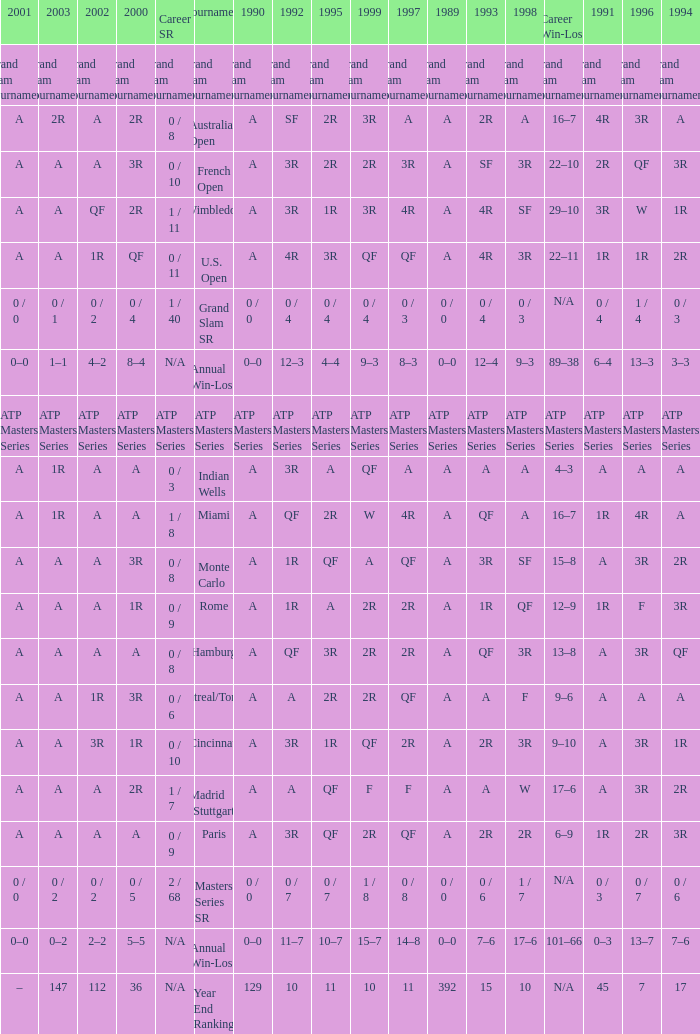Parse the table in full. {'header': ['2001', '2003', '2002', '2000', 'Career SR', 'Tournament', '1990', '1992', '1995', '1999', '1997', '1989', '1993', '1998', 'Career Win-Loss', '1991', '1996', '1994'], 'rows': [['Grand Slam Tournaments', 'Grand Slam Tournaments', 'Grand Slam Tournaments', 'Grand Slam Tournaments', 'Grand Slam Tournaments', 'Grand Slam Tournaments', 'Grand Slam Tournaments', 'Grand Slam Tournaments', 'Grand Slam Tournaments', 'Grand Slam Tournaments', 'Grand Slam Tournaments', 'Grand Slam Tournaments', 'Grand Slam Tournaments', 'Grand Slam Tournaments', 'Grand Slam Tournaments', 'Grand Slam Tournaments', 'Grand Slam Tournaments', 'Grand Slam Tournaments'], ['A', '2R', 'A', '2R', '0 / 8', 'Australian Open', 'A', 'SF', '2R', '3R', 'A', 'A', '2R', 'A', '16–7', '4R', '3R', 'A'], ['A', 'A', 'A', '3R', '0 / 10', 'French Open', 'A', '3R', '2R', '2R', '3R', 'A', 'SF', '3R', '22–10', '2R', 'QF', '3R'], ['A', 'A', 'QF', '2R', '1 / 11', 'Wimbledon', 'A', '3R', '1R', '3R', '4R', 'A', '4R', 'SF', '29–10', '3R', 'W', '1R'], ['A', 'A', '1R', 'QF', '0 / 11', 'U.S. Open', 'A', '4R', '3R', 'QF', 'QF', 'A', '4R', '3R', '22–11', '1R', '1R', '2R'], ['0 / 0', '0 / 1', '0 / 2', '0 / 4', '1 / 40', 'Grand Slam SR', '0 / 0', '0 / 4', '0 / 4', '0 / 4', '0 / 3', '0 / 0', '0 / 4', '0 / 3', 'N/A', '0 / 4', '1 / 4', '0 / 3'], ['0–0', '1–1', '4–2', '8–4', 'N/A', 'Annual Win-Loss', '0–0', '12–3', '4–4', '9–3', '8–3', '0–0', '12–4', '9–3', '89–38', '6–4', '13–3', '3–3'], ['ATP Masters Series', 'ATP Masters Series', 'ATP Masters Series', 'ATP Masters Series', 'ATP Masters Series', 'ATP Masters Series', 'ATP Masters Series', 'ATP Masters Series', 'ATP Masters Series', 'ATP Masters Series', 'ATP Masters Series', 'ATP Masters Series', 'ATP Masters Series', 'ATP Masters Series', 'ATP Masters Series', 'ATP Masters Series', 'ATP Masters Series', 'ATP Masters Series'], ['A', '1R', 'A', 'A', '0 / 3', 'Indian Wells', 'A', '3R', 'A', 'QF', 'A', 'A', 'A', 'A', '4–3', 'A', 'A', 'A'], ['A', '1R', 'A', 'A', '1 / 8', 'Miami', 'A', 'QF', '2R', 'W', '4R', 'A', 'QF', 'A', '16–7', '1R', '4R', 'A'], ['A', 'A', 'A', '3R', '0 / 8', 'Monte Carlo', 'A', '1R', 'QF', 'A', 'QF', 'A', '3R', 'SF', '15–8', 'A', '3R', '2R'], ['A', 'A', 'A', '1R', '0 / 9', 'Rome', 'A', '1R', 'A', '2R', '2R', 'A', '1R', 'QF', '12–9', '1R', 'F', '3R'], ['A', 'A', 'A', 'A', '0 / 8', 'Hamburg', 'A', 'QF', '3R', '2R', '2R', 'A', 'QF', '3R', '13–8', 'A', '3R', 'QF'], ['A', 'A', '1R', '3R', '0 / 6', 'Montreal/Toronto', 'A', 'A', '2R', '2R', 'QF', 'A', 'A', 'F', '9–6', 'A', 'A', 'A'], ['A', 'A', '3R', '1R', '0 / 10', 'Cincinnati', 'A', '3R', '1R', 'QF', '2R', 'A', '2R', '3R', '9–10', 'A', '3R', '1R'], ['A', 'A', 'A', '2R', '1 / 7', 'Madrid (Stuttgart)', 'A', 'A', 'QF', 'F', 'F', 'A', 'A', 'W', '17–6', 'A', '3R', '2R'], ['A', 'A', 'A', 'A', '0 / 9', 'Paris', 'A', '3R', 'QF', '2R', 'QF', 'A', '2R', '2R', '6–9', '1R', '2R', '3R'], ['0 / 0', '0 / 2', '0 / 2', '0 / 5', '2 / 68', 'Masters Series SR', '0 / 0', '0 / 7', '0 / 7', '1 / 8', '0 / 8', '0 / 0', '0 / 6', '1 / 7', 'N/A', '0 / 3', '0 / 7', '0 / 6'], ['0–0', '0–2', '2–2', '5–5', 'N/A', 'Annual Win-Loss', '0–0', '11–7', '10–7', '15–7', '14–8', '0–0', '7–6', '17–6', '101–66', '0–3', '13–7', '7–6'], ['–', '147', '112', '36', 'N/A', 'Year End Ranking', '129', '10', '11', '10', '11', '392', '15', '10', 'N/A', '45', '7', '17']]} What is the valuation in 1997 when the valuation in 1989 is a, 1995 is qf, 1996 is 3r and the career sr QF. 